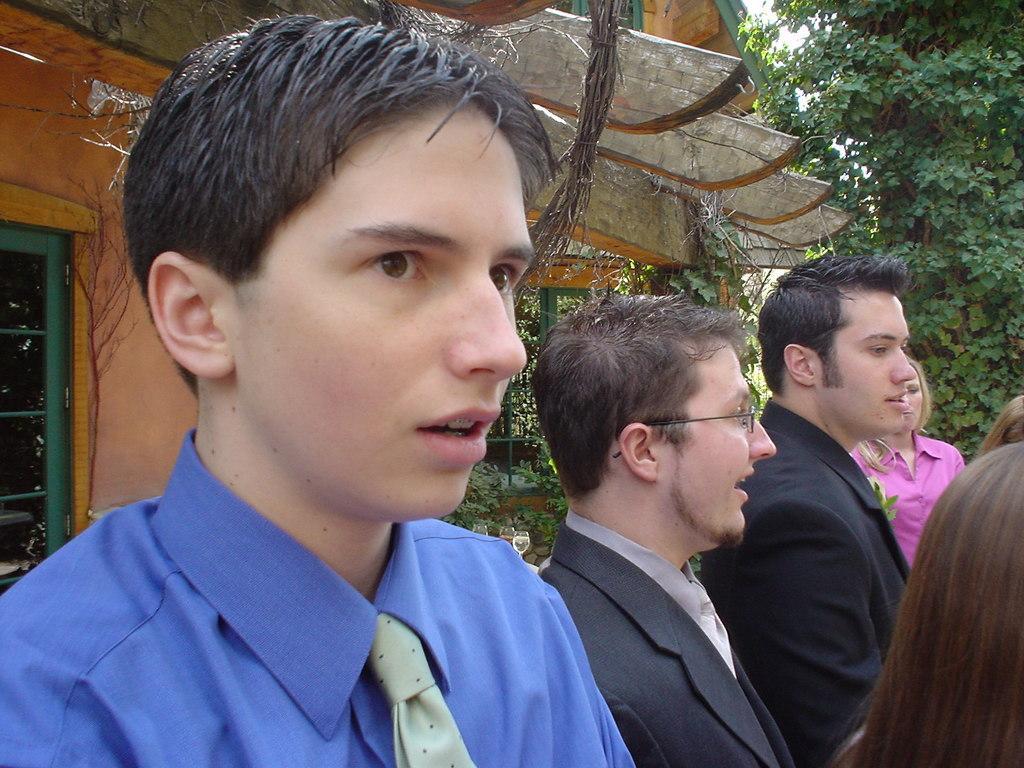How would you summarize this image in a sentence or two? This image is taken outdoors. In the background there is a house with a wall, a window and a roof. There are many trees and plants on the ground. On the left side of the image there is a boy. On the right side of the image there are a few people standing on the ground. 